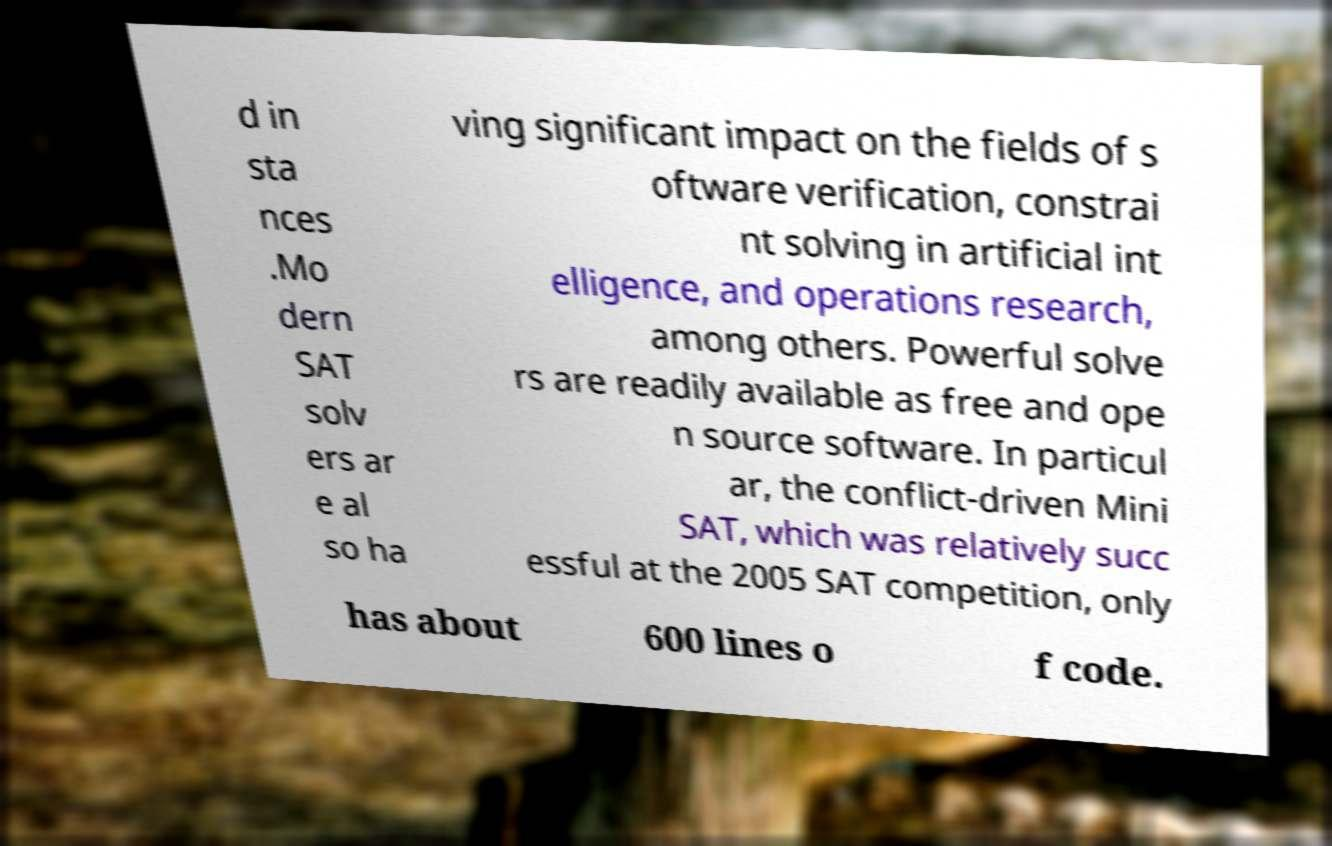Could you assist in decoding the text presented in this image and type it out clearly? d in sta nces .Mo dern SAT solv ers ar e al so ha ving significant impact on the fields of s oftware verification, constrai nt solving in artificial int elligence, and operations research, among others. Powerful solve rs are readily available as free and ope n source software. In particul ar, the conflict-driven Mini SAT, which was relatively succ essful at the 2005 SAT competition, only has about 600 lines o f code. 